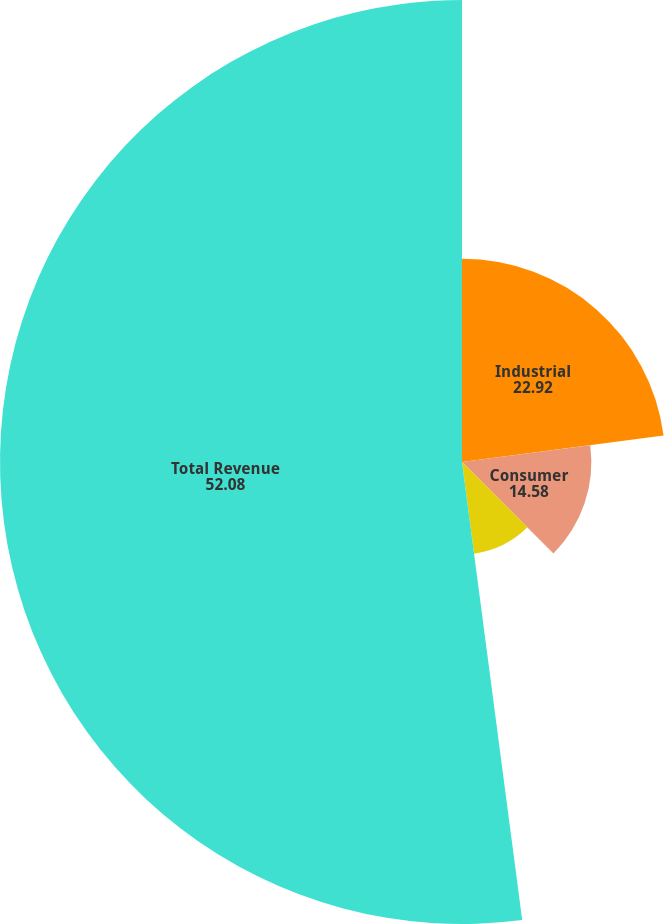Convert chart. <chart><loc_0><loc_0><loc_500><loc_500><pie_chart><fcel>Industrial<fcel>Consumer<fcel>Communications<fcel>Total Revenue<nl><fcel>22.92%<fcel>14.58%<fcel>10.42%<fcel>52.08%<nl></chart> 